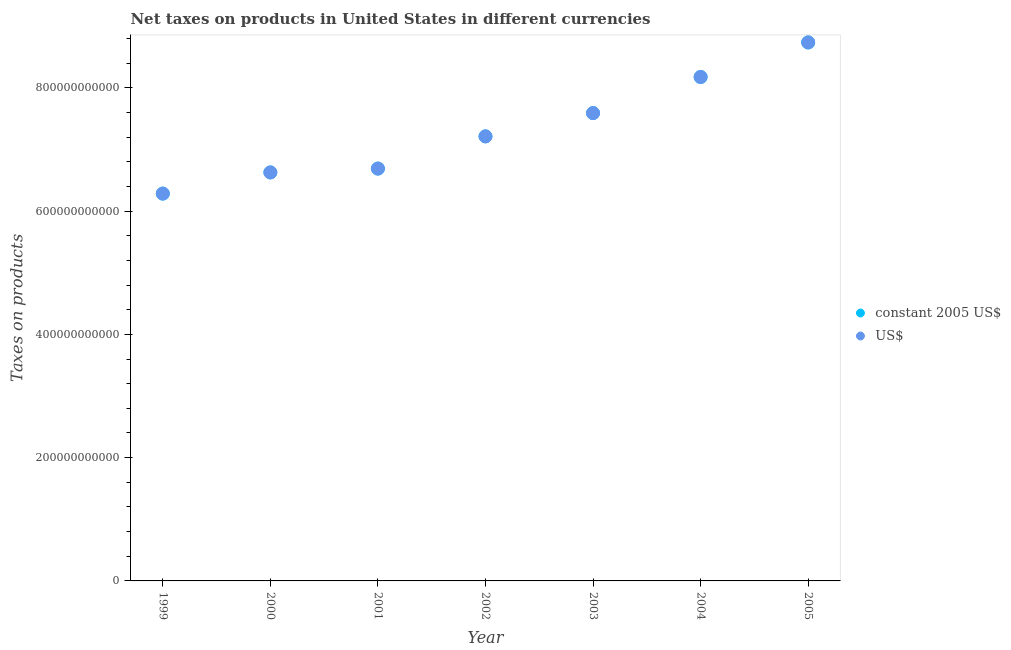How many different coloured dotlines are there?
Keep it short and to the point. 2. What is the net taxes in constant 2005 us$ in 2000?
Keep it short and to the point. 6.63e+11. Across all years, what is the maximum net taxes in constant 2005 us$?
Offer a terse response. 8.74e+11. Across all years, what is the minimum net taxes in constant 2005 us$?
Make the answer very short. 6.28e+11. In which year was the net taxes in constant 2005 us$ maximum?
Keep it short and to the point. 2005. What is the total net taxes in us$ in the graph?
Ensure brevity in your answer.  5.13e+12. What is the difference between the net taxes in us$ in 1999 and that in 2002?
Your answer should be compact. -9.28e+1. What is the difference between the net taxes in us$ in 2001 and the net taxes in constant 2005 us$ in 1999?
Make the answer very short. 4.06e+1. What is the average net taxes in constant 2005 us$ per year?
Keep it short and to the point. 7.33e+11. In the year 2004, what is the difference between the net taxes in us$ and net taxes in constant 2005 us$?
Ensure brevity in your answer.  0. What is the ratio of the net taxes in constant 2005 us$ in 1999 to that in 2000?
Provide a succinct answer. 0.95. What is the difference between the highest and the second highest net taxes in constant 2005 us$?
Offer a terse response. 5.61e+1. What is the difference between the highest and the lowest net taxes in us$?
Your answer should be compact. 2.45e+11. In how many years, is the net taxes in constant 2005 us$ greater than the average net taxes in constant 2005 us$ taken over all years?
Keep it short and to the point. 3. Is the sum of the net taxes in us$ in 2000 and 2002 greater than the maximum net taxes in constant 2005 us$ across all years?
Make the answer very short. Yes. How many dotlines are there?
Offer a very short reply. 2. How many years are there in the graph?
Make the answer very short. 7. What is the difference between two consecutive major ticks on the Y-axis?
Offer a terse response. 2.00e+11. Are the values on the major ticks of Y-axis written in scientific E-notation?
Your answer should be very brief. No. Does the graph contain any zero values?
Provide a short and direct response. No. How many legend labels are there?
Your response must be concise. 2. How are the legend labels stacked?
Ensure brevity in your answer.  Vertical. What is the title of the graph?
Give a very brief answer. Net taxes on products in United States in different currencies. What is the label or title of the Y-axis?
Provide a succinct answer. Taxes on products. What is the Taxes on products of constant 2005 US$ in 1999?
Offer a very short reply. 6.28e+11. What is the Taxes on products of US$ in 1999?
Offer a terse response. 6.28e+11. What is the Taxes on products in constant 2005 US$ in 2000?
Offer a terse response. 6.63e+11. What is the Taxes on products of US$ in 2000?
Ensure brevity in your answer.  6.63e+11. What is the Taxes on products in constant 2005 US$ in 2001?
Make the answer very short. 6.69e+11. What is the Taxes on products in US$ in 2001?
Provide a succinct answer. 6.69e+11. What is the Taxes on products in constant 2005 US$ in 2002?
Ensure brevity in your answer.  7.21e+11. What is the Taxes on products in US$ in 2002?
Provide a succinct answer. 7.21e+11. What is the Taxes on products of constant 2005 US$ in 2003?
Your answer should be compact. 7.59e+11. What is the Taxes on products in US$ in 2003?
Your answer should be compact. 7.59e+11. What is the Taxes on products of constant 2005 US$ in 2004?
Provide a succinct answer. 8.18e+11. What is the Taxes on products of US$ in 2004?
Your answer should be very brief. 8.18e+11. What is the Taxes on products in constant 2005 US$ in 2005?
Ensure brevity in your answer.  8.74e+11. What is the Taxes on products of US$ in 2005?
Give a very brief answer. 8.74e+11. Across all years, what is the maximum Taxes on products in constant 2005 US$?
Keep it short and to the point. 8.74e+11. Across all years, what is the maximum Taxes on products of US$?
Make the answer very short. 8.74e+11. Across all years, what is the minimum Taxes on products of constant 2005 US$?
Provide a succinct answer. 6.28e+11. Across all years, what is the minimum Taxes on products of US$?
Provide a succinct answer. 6.28e+11. What is the total Taxes on products in constant 2005 US$ in the graph?
Your response must be concise. 5.13e+12. What is the total Taxes on products of US$ in the graph?
Ensure brevity in your answer.  5.13e+12. What is the difference between the Taxes on products in constant 2005 US$ in 1999 and that in 2000?
Keep it short and to the point. -3.43e+1. What is the difference between the Taxes on products of US$ in 1999 and that in 2000?
Offer a terse response. -3.43e+1. What is the difference between the Taxes on products in constant 2005 US$ in 1999 and that in 2001?
Keep it short and to the point. -4.06e+1. What is the difference between the Taxes on products of US$ in 1999 and that in 2001?
Your response must be concise. -4.06e+1. What is the difference between the Taxes on products of constant 2005 US$ in 1999 and that in 2002?
Offer a terse response. -9.28e+1. What is the difference between the Taxes on products in US$ in 1999 and that in 2002?
Keep it short and to the point. -9.28e+1. What is the difference between the Taxes on products in constant 2005 US$ in 1999 and that in 2003?
Give a very brief answer. -1.31e+11. What is the difference between the Taxes on products in US$ in 1999 and that in 2003?
Your response must be concise. -1.31e+11. What is the difference between the Taxes on products in constant 2005 US$ in 1999 and that in 2004?
Offer a terse response. -1.89e+11. What is the difference between the Taxes on products of US$ in 1999 and that in 2004?
Provide a succinct answer. -1.89e+11. What is the difference between the Taxes on products in constant 2005 US$ in 1999 and that in 2005?
Ensure brevity in your answer.  -2.45e+11. What is the difference between the Taxes on products in US$ in 1999 and that in 2005?
Provide a succinct answer. -2.45e+11. What is the difference between the Taxes on products in constant 2005 US$ in 2000 and that in 2001?
Provide a short and direct response. -6.25e+09. What is the difference between the Taxes on products of US$ in 2000 and that in 2001?
Your answer should be compact. -6.25e+09. What is the difference between the Taxes on products in constant 2005 US$ in 2000 and that in 2002?
Ensure brevity in your answer.  -5.85e+1. What is the difference between the Taxes on products in US$ in 2000 and that in 2002?
Make the answer very short. -5.85e+1. What is the difference between the Taxes on products in constant 2005 US$ in 2000 and that in 2003?
Make the answer very short. -9.62e+1. What is the difference between the Taxes on products of US$ in 2000 and that in 2003?
Offer a terse response. -9.62e+1. What is the difference between the Taxes on products of constant 2005 US$ in 2000 and that in 2004?
Provide a succinct answer. -1.55e+11. What is the difference between the Taxes on products in US$ in 2000 and that in 2004?
Ensure brevity in your answer.  -1.55e+11. What is the difference between the Taxes on products in constant 2005 US$ in 2000 and that in 2005?
Provide a short and direct response. -2.11e+11. What is the difference between the Taxes on products of US$ in 2000 and that in 2005?
Ensure brevity in your answer.  -2.11e+11. What is the difference between the Taxes on products of constant 2005 US$ in 2001 and that in 2002?
Your answer should be very brief. -5.22e+1. What is the difference between the Taxes on products of US$ in 2001 and that in 2002?
Your answer should be compact. -5.22e+1. What is the difference between the Taxes on products of constant 2005 US$ in 2001 and that in 2003?
Offer a terse response. -9.00e+1. What is the difference between the Taxes on products of US$ in 2001 and that in 2003?
Provide a short and direct response. -9.00e+1. What is the difference between the Taxes on products in constant 2005 US$ in 2001 and that in 2004?
Offer a very short reply. -1.49e+11. What is the difference between the Taxes on products in US$ in 2001 and that in 2004?
Your answer should be compact. -1.49e+11. What is the difference between the Taxes on products of constant 2005 US$ in 2001 and that in 2005?
Your answer should be very brief. -2.05e+11. What is the difference between the Taxes on products of US$ in 2001 and that in 2005?
Offer a very short reply. -2.05e+11. What is the difference between the Taxes on products of constant 2005 US$ in 2002 and that in 2003?
Keep it short and to the point. -3.77e+1. What is the difference between the Taxes on products of US$ in 2002 and that in 2003?
Give a very brief answer. -3.77e+1. What is the difference between the Taxes on products of constant 2005 US$ in 2002 and that in 2004?
Your answer should be compact. -9.63e+1. What is the difference between the Taxes on products of US$ in 2002 and that in 2004?
Offer a very short reply. -9.63e+1. What is the difference between the Taxes on products in constant 2005 US$ in 2002 and that in 2005?
Give a very brief answer. -1.52e+11. What is the difference between the Taxes on products of US$ in 2002 and that in 2005?
Offer a terse response. -1.52e+11. What is the difference between the Taxes on products in constant 2005 US$ in 2003 and that in 2004?
Your answer should be compact. -5.86e+1. What is the difference between the Taxes on products in US$ in 2003 and that in 2004?
Your answer should be compact. -5.86e+1. What is the difference between the Taxes on products of constant 2005 US$ in 2003 and that in 2005?
Offer a very short reply. -1.15e+11. What is the difference between the Taxes on products of US$ in 2003 and that in 2005?
Ensure brevity in your answer.  -1.15e+11. What is the difference between the Taxes on products in constant 2005 US$ in 2004 and that in 2005?
Offer a terse response. -5.61e+1. What is the difference between the Taxes on products in US$ in 2004 and that in 2005?
Your answer should be very brief. -5.61e+1. What is the difference between the Taxes on products in constant 2005 US$ in 1999 and the Taxes on products in US$ in 2000?
Make the answer very short. -3.43e+1. What is the difference between the Taxes on products of constant 2005 US$ in 1999 and the Taxes on products of US$ in 2001?
Your answer should be very brief. -4.06e+1. What is the difference between the Taxes on products of constant 2005 US$ in 1999 and the Taxes on products of US$ in 2002?
Keep it short and to the point. -9.28e+1. What is the difference between the Taxes on products in constant 2005 US$ in 1999 and the Taxes on products in US$ in 2003?
Your response must be concise. -1.31e+11. What is the difference between the Taxes on products in constant 2005 US$ in 1999 and the Taxes on products in US$ in 2004?
Ensure brevity in your answer.  -1.89e+11. What is the difference between the Taxes on products of constant 2005 US$ in 1999 and the Taxes on products of US$ in 2005?
Keep it short and to the point. -2.45e+11. What is the difference between the Taxes on products in constant 2005 US$ in 2000 and the Taxes on products in US$ in 2001?
Offer a very short reply. -6.25e+09. What is the difference between the Taxes on products in constant 2005 US$ in 2000 and the Taxes on products in US$ in 2002?
Ensure brevity in your answer.  -5.85e+1. What is the difference between the Taxes on products in constant 2005 US$ in 2000 and the Taxes on products in US$ in 2003?
Offer a very short reply. -9.62e+1. What is the difference between the Taxes on products of constant 2005 US$ in 2000 and the Taxes on products of US$ in 2004?
Provide a succinct answer. -1.55e+11. What is the difference between the Taxes on products of constant 2005 US$ in 2000 and the Taxes on products of US$ in 2005?
Give a very brief answer. -2.11e+11. What is the difference between the Taxes on products in constant 2005 US$ in 2001 and the Taxes on products in US$ in 2002?
Your response must be concise. -5.22e+1. What is the difference between the Taxes on products of constant 2005 US$ in 2001 and the Taxes on products of US$ in 2003?
Provide a succinct answer. -9.00e+1. What is the difference between the Taxes on products in constant 2005 US$ in 2001 and the Taxes on products in US$ in 2004?
Ensure brevity in your answer.  -1.49e+11. What is the difference between the Taxes on products in constant 2005 US$ in 2001 and the Taxes on products in US$ in 2005?
Your answer should be compact. -2.05e+11. What is the difference between the Taxes on products in constant 2005 US$ in 2002 and the Taxes on products in US$ in 2003?
Keep it short and to the point. -3.77e+1. What is the difference between the Taxes on products of constant 2005 US$ in 2002 and the Taxes on products of US$ in 2004?
Your answer should be very brief. -9.63e+1. What is the difference between the Taxes on products of constant 2005 US$ in 2002 and the Taxes on products of US$ in 2005?
Your response must be concise. -1.52e+11. What is the difference between the Taxes on products in constant 2005 US$ in 2003 and the Taxes on products in US$ in 2004?
Offer a terse response. -5.86e+1. What is the difference between the Taxes on products in constant 2005 US$ in 2003 and the Taxes on products in US$ in 2005?
Give a very brief answer. -1.15e+11. What is the difference between the Taxes on products in constant 2005 US$ in 2004 and the Taxes on products in US$ in 2005?
Provide a short and direct response. -5.61e+1. What is the average Taxes on products in constant 2005 US$ per year?
Your response must be concise. 7.33e+11. What is the average Taxes on products in US$ per year?
Provide a short and direct response. 7.33e+11. In the year 2000, what is the difference between the Taxes on products in constant 2005 US$ and Taxes on products in US$?
Provide a succinct answer. 0. In the year 2003, what is the difference between the Taxes on products in constant 2005 US$ and Taxes on products in US$?
Your response must be concise. 0. In the year 2004, what is the difference between the Taxes on products of constant 2005 US$ and Taxes on products of US$?
Your response must be concise. 0. In the year 2005, what is the difference between the Taxes on products of constant 2005 US$ and Taxes on products of US$?
Your response must be concise. 0. What is the ratio of the Taxes on products of constant 2005 US$ in 1999 to that in 2000?
Keep it short and to the point. 0.95. What is the ratio of the Taxes on products of US$ in 1999 to that in 2000?
Provide a short and direct response. 0.95. What is the ratio of the Taxes on products of constant 2005 US$ in 1999 to that in 2001?
Your response must be concise. 0.94. What is the ratio of the Taxes on products in US$ in 1999 to that in 2001?
Offer a very short reply. 0.94. What is the ratio of the Taxes on products in constant 2005 US$ in 1999 to that in 2002?
Ensure brevity in your answer.  0.87. What is the ratio of the Taxes on products of US$ in 1999 to that in 2002?
Keep it short and to the point. 0.87. What is the ratio of the Taxes on products of constant 2005 US$ in 1999 to that in 2003?
Provide a short and direct response. 0.83. What is the ratio of the Taxes on products in US$ in 1999 to that in 2003?
Make the answer very short. 0.83. What is the ratio of the Taxes on products of constant 2005 US$ in 1999 to that in 2004?
Your answer should be very brief. 0.77. What is the ratio of the Taxes on products in US$ in 1999 to that in 2004?
Offer a very short reply. 0.77. What is the ratio of the Taxes on products in constant 2005 US$ in 1999 to that in 2005?
Give a very brief answer. 0.72. What is the ratio of the Taxes on products of US$ in 1999 to that in 2005?
Your answer should be compact. 0.72. What is the ratio of the Taxes on products of constant 2005 US$ in 2000 to that in 2001?
Provide a succinct answer. 0.99. What is the ratio of the Taxes on products in US$ in 2000 to that in 2001?
Offer a very short reply. 0.99. What is the ratio of the Taxes on products of constant 2005 US$ in 2000 to that in 2002?
Provide a succinct answer. 0.92. What is the ratio of the Taxes on products in US$ in 2000 to that in 2002?
Offer a terse response. 0.92. What is the ratio of the Taxes on products in constant 2005 US$ in 2000 to that in 2003?
Your response must be concise. 0.87. What is the ratio of the Taxes on products in US$ in 2000 to that in 2003?
Ensure brevity in your answer.  0.87. What is the ratio of the Taxes on products of constant 2005 US$ in 2000 to that in 2004?
Make the answer very short. 0.81. What is the ratio of the Taxes on products of US$ in 2000 to that in 2004?
Keep it short and to the point. 0.81. What is the ratio of the Taxes on products of constant 2005 US$ in 2000 to that in 2005?
Offer a terse response. 0.76. What is the ratio of the Taxes on products of US$ in 2000 to that in 2005?
Provide a succinct answer. 0.76. What is the ratio of the Taxes on products of constant 2005 US$ in 2001 to that in 2002?
Provide a succinct answer. 0.93. What is the ratio of the Taxes on products in US$ in 2001 to that in 2002?
Your response must be concise. 0.93. What is the ratio of the Taxes on products in constant 2005 US$ in 2001 to that in 2003?
Offer a very short reply. 0.88. What is the ratio of the Taxes on products of US$ in 2001 to that in 2003?
Ensure brevity in your answer.  0.88. What is the ratio of the Taxes on products in constant 2005 US$ in 2001 to that in 2004?
Ensure brevity in your answer.  0.82. What is the ratio of the Taxes on products of US$ in 2001 to that in 2004?
Provide a short and direct response. 0.82. What is the ratio of the Taxes on products in constant 2005 US$ in 2001 to that in 2005?
Provide a short and direct response. 0.77. What is the ratio of the Taxes on products of US$ in 2001 to that in 2005?
Your answer should be compact. 0.77. What is the ratio of the Taxes on products of constant 2005 US$ in 2002 to that in 2003?
Give a very brief answer. 0.95. What is the ratio of the Taxes on products in US$ in 2002 to that in 2003?
Make the answer very short. 0.95. What is the ratio of the Taxes on products in constant 2005 US$ in 2002 to that in 2004?
Make the answer very short. 0.88. What is the ratio of the Taxes on products of US$ in 2002 to that in 2004?
Your answer should be very brief. 0.88. What is the ratio of the Taxes on products in constant 2005 US$ in 2002 to that in 2005?
Your answer should be very brief. 0.83. What is the ratio of the Taxes on products in US$ in 2002 to that in 2005?
Make the answer very short. 0.83. What is the ratio of the Taxes on products of constant 2005 US$ in 2003 to that in 2004?
Offer a very short reply. 0.93. What is the ratio of the Taxes on products in US$ in 2003 to that in 2004?
Make the answer very short. 0.93. What is the ratio of the Taxes on products of constant 2005 US$ in 2003 to that in 2005?
Keep it short and to the point. 0.87. What is the ratio of the Taxes on products in US$ in 2003 to that in 2005?
Provide a short and direct response. 0.87. What is the ratio of the Taxes on products of constant 2005 US$ in 2004 to that in 2005?
Your response must be concise. 0.94. What is the ratio of the Taxes on products of US$ in 2004 to that in 2005?
Ensure brevity in your answer.  0.94. What is the difference between the highest and the second highest Taxes on products in constant 2005 US$?
Provide a short and direct response. 5.61e+1. What is the difference between the highest and the second highest Taxes on products of US$?
Ensure brevity in your answer.  5.61e+1. What is the difference between the highest and the lowest Taxes on products in constant 2005 US$?
Provide a succinct answer. 2.45e+11. What is the difference between the highest and the lowest Taxes on products in US$?
Your response must be concise. 2.45e+11. 